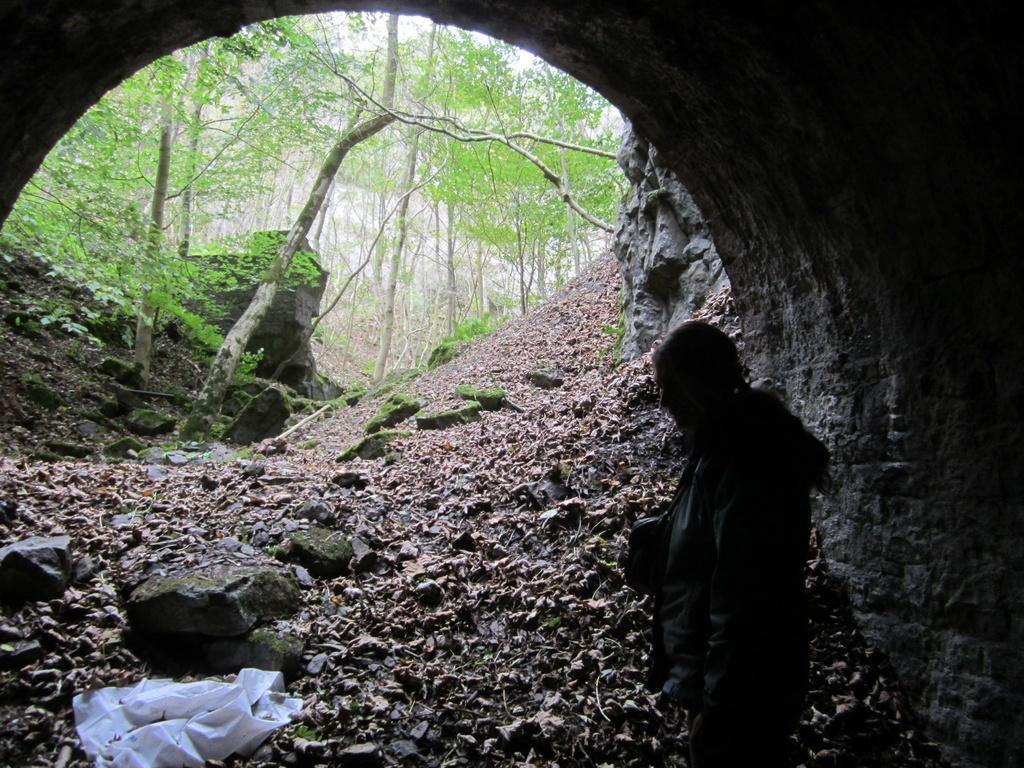Can you describe this image briefly? It is the inside view of the tunnel. Here we can see a person is standing. Background we can see stones, rocks, trees, plants. At the bottom of the image, we can see a white color object. 